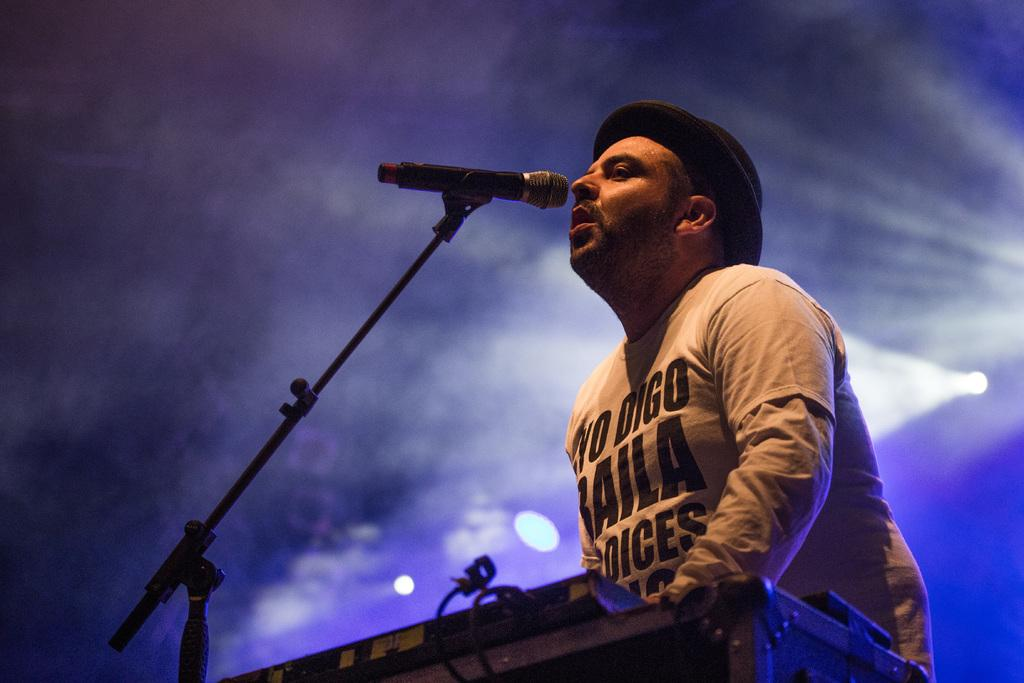Who is the main subject in the image? There is a man in the image. What object is in front of the man? There is a microphone in front of the man. What can be seen in the background of the image? There are lights visible in the background of the image. What type of flame can be seen coming from the microphone in the image? There is no flame present in the image; it features a man with a microphone in front of him and lights in the background. 